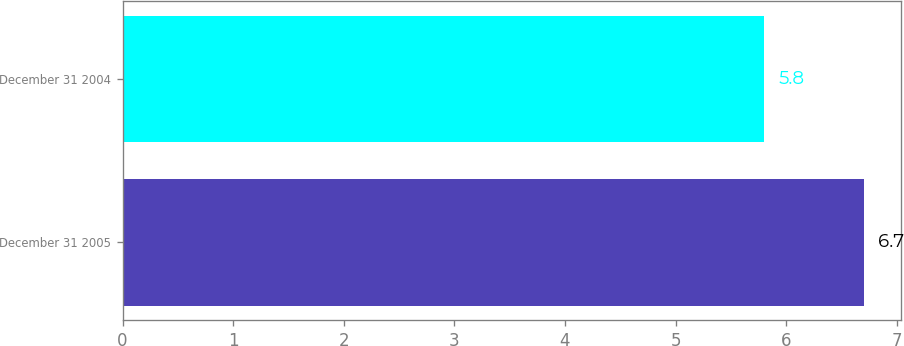<chart> <loc_0><loc_0><loc_500><loc_500><bar_chart><fcel>December 31 2005<fcel>December 31 2004<nl><fcel>6.7<fcel>5.8<nl></chart> 